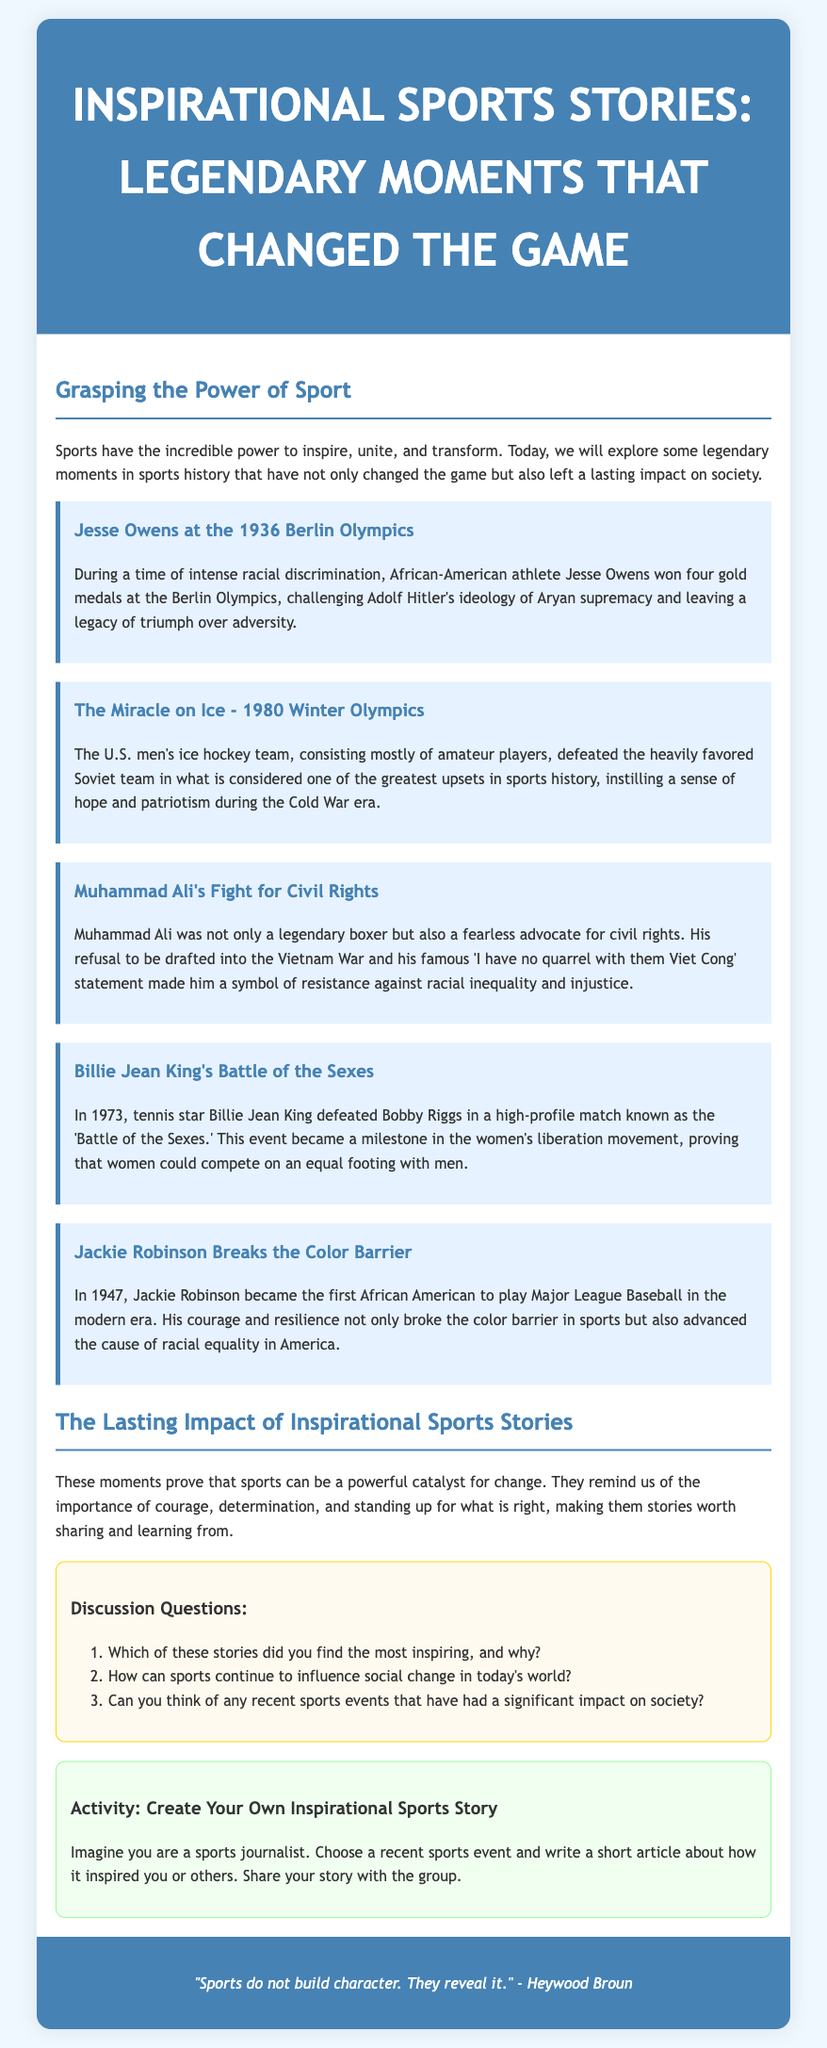What is the title of the lesson plan? The title is specified in the header of the document as the main subject of the lesson plan.
Answer: Inspirational Sports Stories: Legendary Moments that Changed the Game Who won four gold medals at the 1936 Berlin Olympics? The story mentions the athlete's name and his achievement at the Olympics.
Answer: Jesse Owens In what year did the 'Battle of the Sexes' take place? The year is mentioned in the context of Billie Jean King's historic match against Bobby Riggs.
Answer: 1973 What was the significant achievement of Jackie Robinson in 1947? The document details his role in breaking the color barrier in sports.
Answer: First African American to play Major League Baseball What major event is referred to as the 'Miracle on Ice'? The document provides information about a specific ice hockey match during the 1980 Winter Olympics.
Answer: U.S. men's ice hockey team's victory over the Soviet team Which athlete is known for his fight for civil rights? The document highlights an athlete who made significant contributions to social justice and civil rights.
Answer: Muhammad Ali What is the main theme of the stories presented in the document? The purpose of the stories, as stated, is to illustrate the influence of sports on society.
Answer: Courage and determination What kind of activity does the lesson plan include? The document specifies that the activity is related to creating an inspirational sports story.
Answer: Create Your Own Inspirational Sports Story 